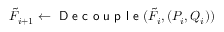<formula> <loc_0><loc_0><loc_500><loc_500>\tilde { F } _ { i + 1 } \gets D e c o u p l e ( \tilde { F } _ { i } , ( P _ { i } , Q _ { i } ) )</formula> 